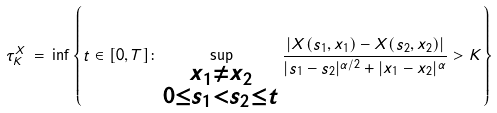<formula> <loc_0><loc_0><loc_500><loc_500>\tau _ { K } ^ { X } \, = \, \inf \left \{ t \in [ 0 , T ] \colon \sup _ { \substack { x _ { 1 } \neq x _ { 2 } \\ 0 \leq s _ { 1 } < s _ { 2 } \leq t } } \frac { \left | X ( s _ { 1 } , x _ { 1 } ) - X ( s _ { 2 } , x _ { 2 } ) \right | } { | s _ { 1 } - s _ { 2 } | ^ { \alpha / 2 } + | x _ { 1 } - x _ { 2 } | ^ { \alpha } } > K \right \}</formula> 